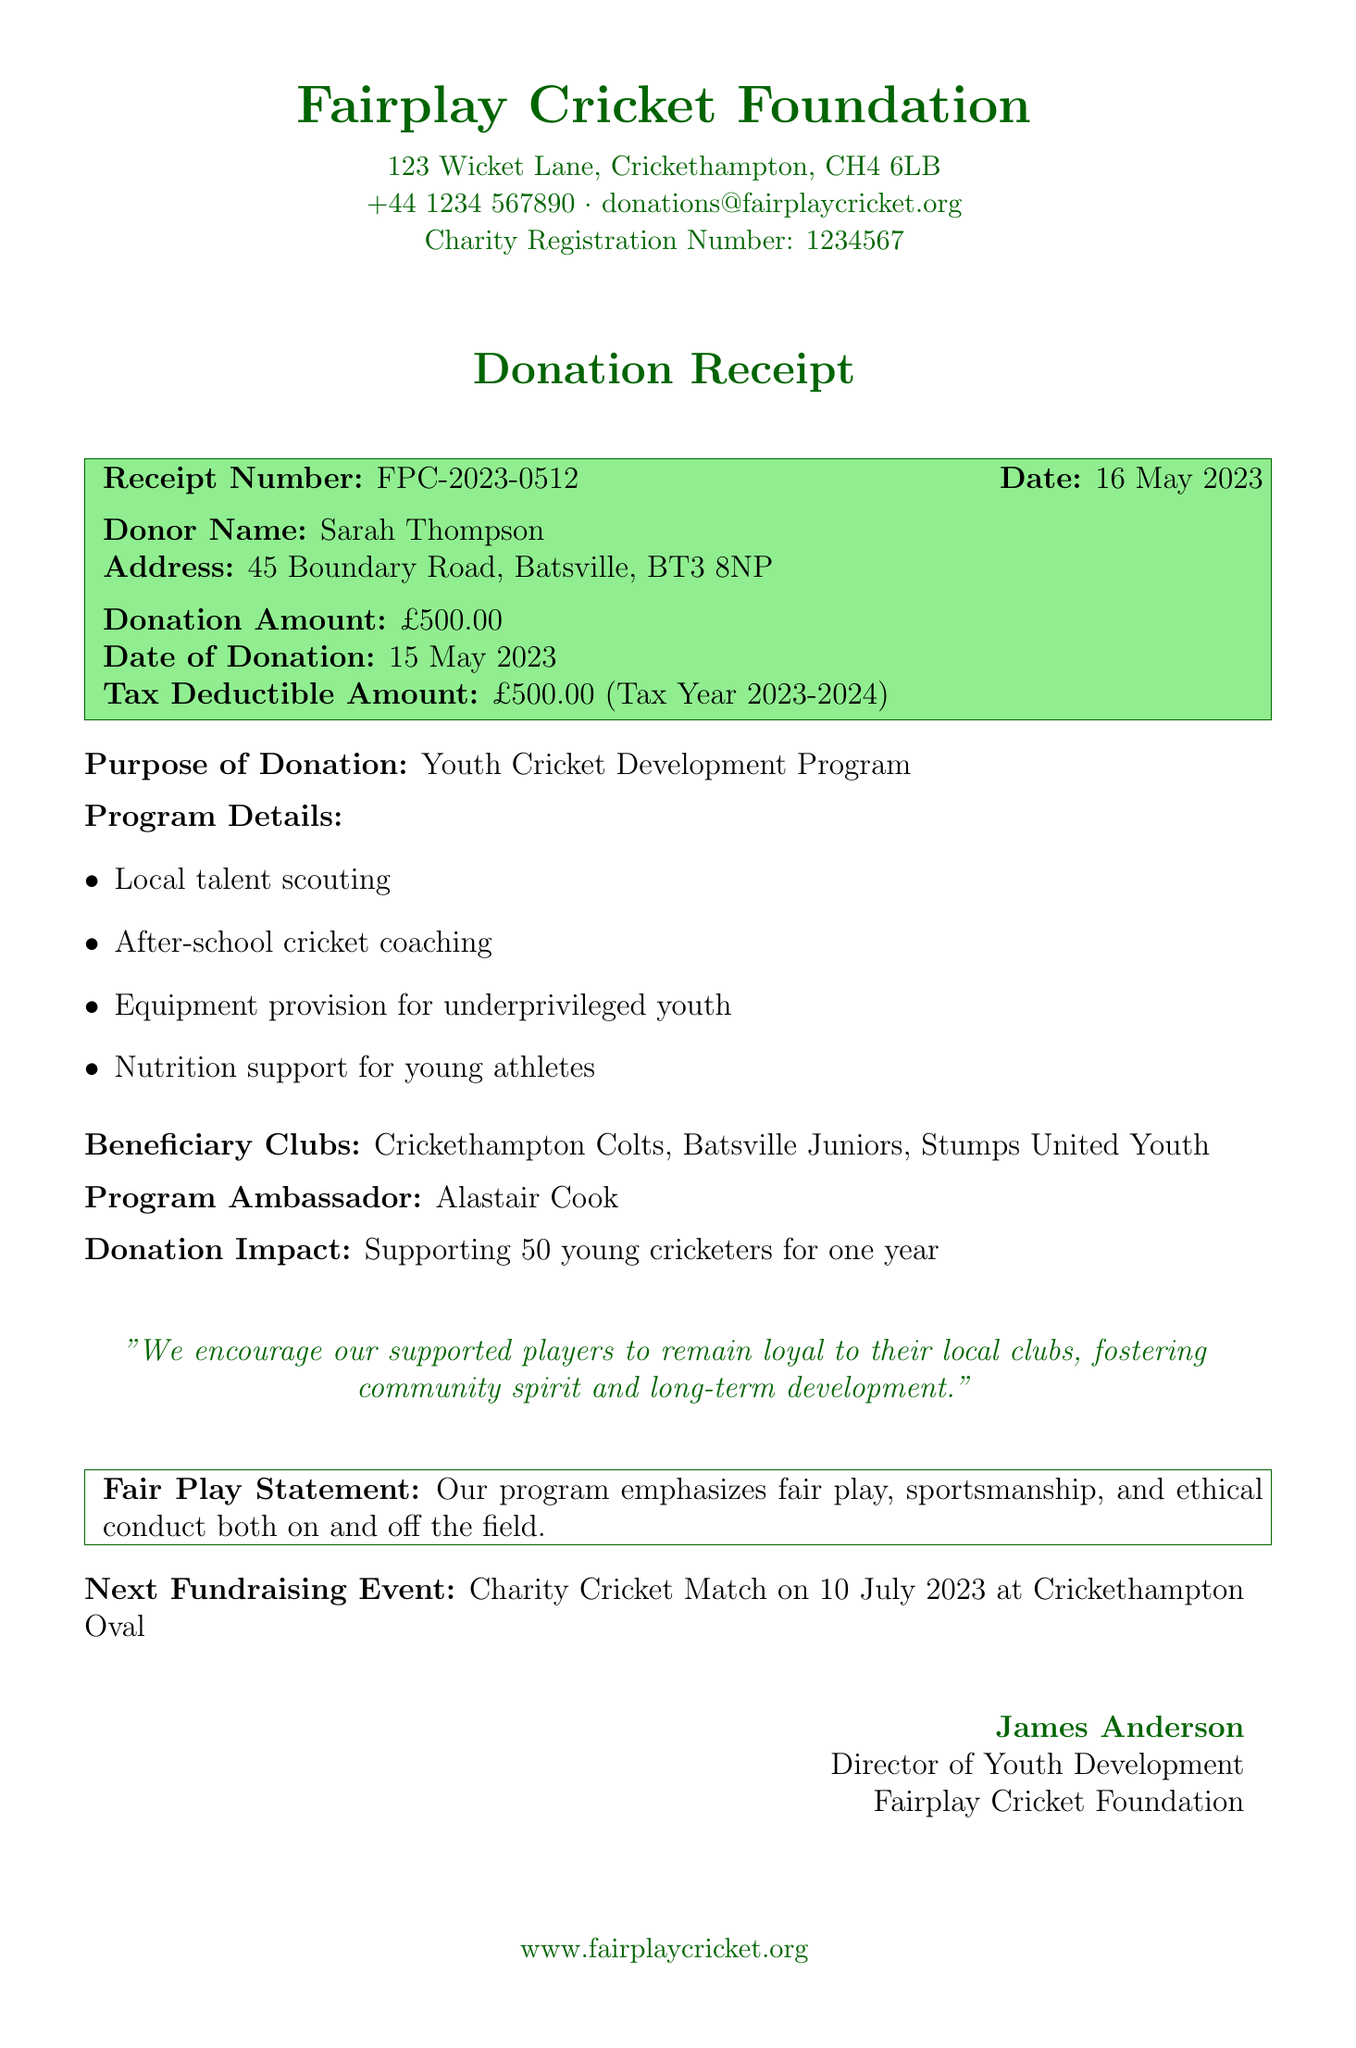What is the name of the organization? The organization listed in the document is the Fairplay Cricket Foundation.
Answer: Fairplay Cricket Foundation What is the donation amount? The document specifies the donation amount made by the donor.
Answer: £500.00 Who is the donor? The document identifies the individual who made the donation.
Answer: Sarah Thompson What is the date of the donation? The date listed in the document for when the donation was made.
Answer: 15 May 2023 What is the purpose of the donation? The document outlines the specific purpose for which the donation was made.
Answer: Youth Cricket Development Program What is the impact of the donation? The document mentions the outcome of the donation in terms of community support.
Answer: Supporting 50 young cricketers for one year What is emphasized in the Fair Play Statement? The Fair Play Statement details the principles upheld by the program.
Answer: Fair play, sportsmanship, and ethical conduct Name one beneficiary club. The document lists clubs that will benefit from the donation.
Answer: Crickethampton Colts What is the next fundraising event? The document provides details of the upcoming fundraising activity.
Answer: Charity Cricket Match Who is the program ambassador? The document names an ambassador representing the program.
Answer: Alastair Cook 